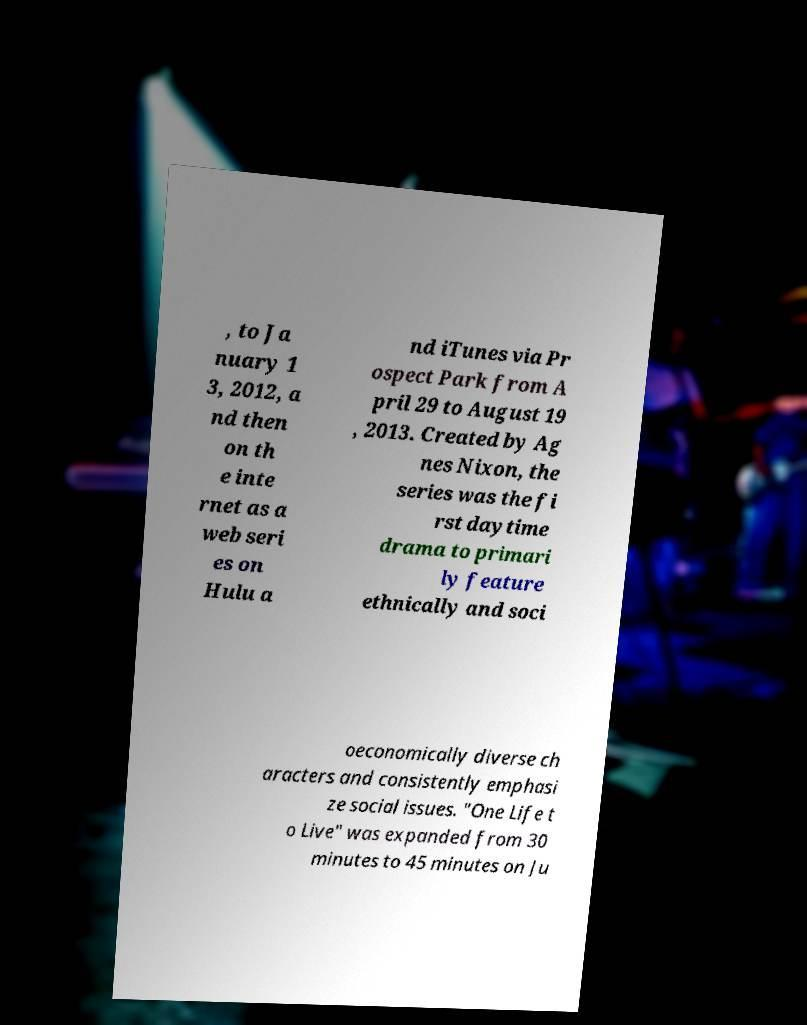Please read and relay the text visible in this image. What does it say? , to Ja nuary 1 3, 2012, a nd then on th e inte rnet as a web seri es on Hulu a nd iTunes via Pr ospect Park from A pril 29 to August 19 , 2013. Created by Ag nes Nixon, the series was the fi rst daytime drama to primari ly feature ethnically and soci oeconomically diverse ch aracters and consistently emphasi ze social issues. "One Life t o Live" was expanded from 30 minutes to 45 minutes on Ju 